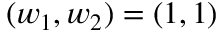<formula> <loc_0><loc_0><loc_500><loc_500>( w _ { 1 } , w _ { 2 } ) = ( 1 , 1 )</formula> 